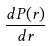Convert formula to latex. <formula><loc_0><loc_0><loc_500><loc_500>\frac { d P ( r ) } { d r }</formula> 